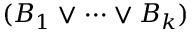Convert formula to latex. <formula><loc_0><loc_0><loc_500><loc_500>( B _ { 1 } \lor \cdots \lor B _ { k } )</formula> 